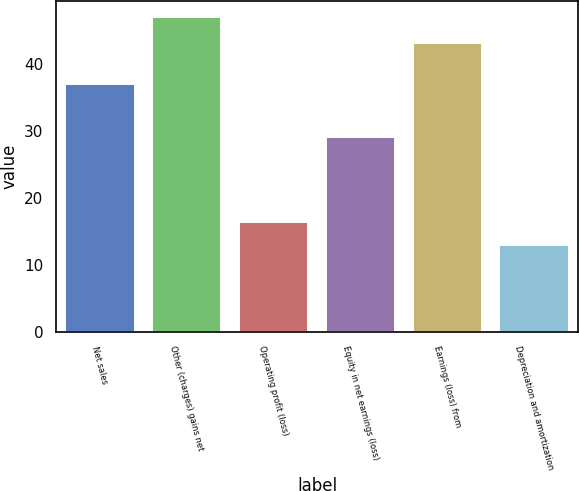Convert chart. <chart><loc_0><loc_0><loc_500><loc_500><bar_chart><fcel>Net sales<fcel>Other (charges) gains net<fcel>Operating profit (loss)<fcel>Equity in net earnings (loss)<fcel>Earnings (loss) from<fcel>Depreciation and amortization<nl><fcel>37<fcel>47<fcel>16.4<fcel>29<fcel>43<fcel>13<nl></chart> 